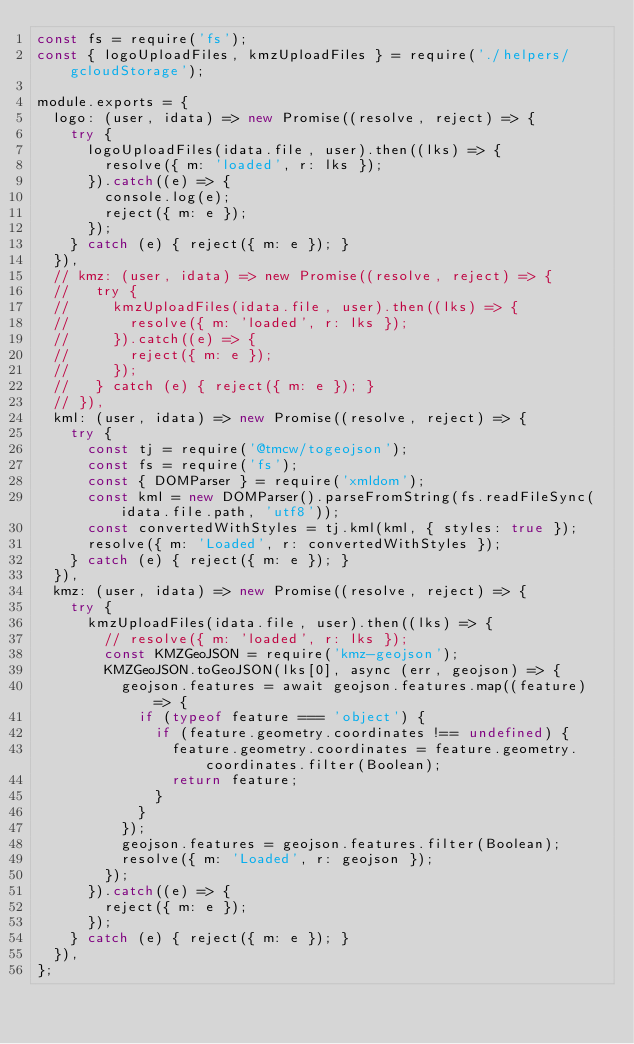Convert code to text. <code><loc_0><loc_0><loc_500><loc_500><_JavaScript_>const fs = require('fs');
const { logoUploadFiles, kmzUploadFiles } = require('./helpers/gcloudStorage');

module.exports = {
  logo: (user, idata) => new Promise((resolve, reject) => {
    try {
      logoUploadFiles(idata.file, user).then((lks) => {
        resolve({ m: 'loaded', r: lks });
      }).catch((e) => {
        console.log(e);
        reject({ m: e });
      });
    } catch (e) { reject({ m: e }); }
  }),
  // kmz: (user, idata) => new Promise((resolve, reject) => {
  //   try {
  //     kmzUploadFiles(idata.file, user).then((lks) => {
  //       resolve({ m: 'loaded', r: lks });
  //     }).catch((e) => {
  //       reject({ m: e });
  //     });
  //   } catch (e) { reject({ m: e }); }
  // }),
  kml: (user, idata) => new Promise((resolve, reject) => {
    try {
      const tj = require('@tmcw/togeojson');
      const fs = require('fs');
      const { DOMParser } = require('xmldom');
      const kml = new DOMParser().parseFromString(fs.readFileSync(idata.file.path, 'utf8'));
      const convertedWithStyles = tj.kml(kml, { styles: true });
      resolve({ m: 'Loaded', r: convertedWithStyles });
    } catch (e) { reject({ m: e }); }
  }),
  kmz: (user, idata) => new Promise((resolve, reject) => {
    try {
      kmzUploadFiles(idata.file, user).then((lks) => {
        // resolve({ m: 'loaded', r: lks });
        const KMZGeoJSON = require('kmz-geojson');
        KMZGeoJSON.toGeoJSON(lks[0], async (err, geojson) => {
          geojson.features = await geojson.features.map((feature) => {
            if (typeof feature === 'object') {
              if (feature.geometry.coordinates !== undefined) {
                feature.geometry.coordinates = feature.geometry.coordinates.filter(Boolean);
                return feature;
              }
            }
          });
          geojson.features = geojson.features.filter(Boolean);
          resolve({ m: 'Loaded', r: geojson });
        });
      }).catch((e) => {
        reject({ m: e });
      });
    } catch (e) { reject({ m: e }); }
  }),
};
</code> 